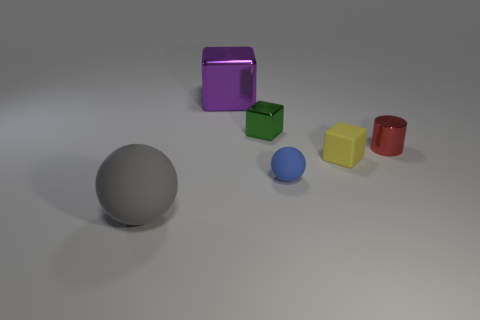Subtract all tiny blocks. How many blocks are left? 1 Add 1 small red matte cylinders. How many objects exist? 7 Subtract all purple blocks. How many blocks are left? 2 Subtract all spheres. How many objects are left? 4 Subtract 1 purple blocks. How many objects are left? 5 Subtract 1 blocks. How many blocks are left? 2 Subtract all blue cubes. Subtract all green spheres. How many cubes are left? 3 Subtract all gray spheres. How many purple cylinders are left? 0 Subtract all spheres. Subtract all red shiny cylinders. How many objects are left? 3 Add 1 gray rubber objects. How many gray rubber objects are left? 2 